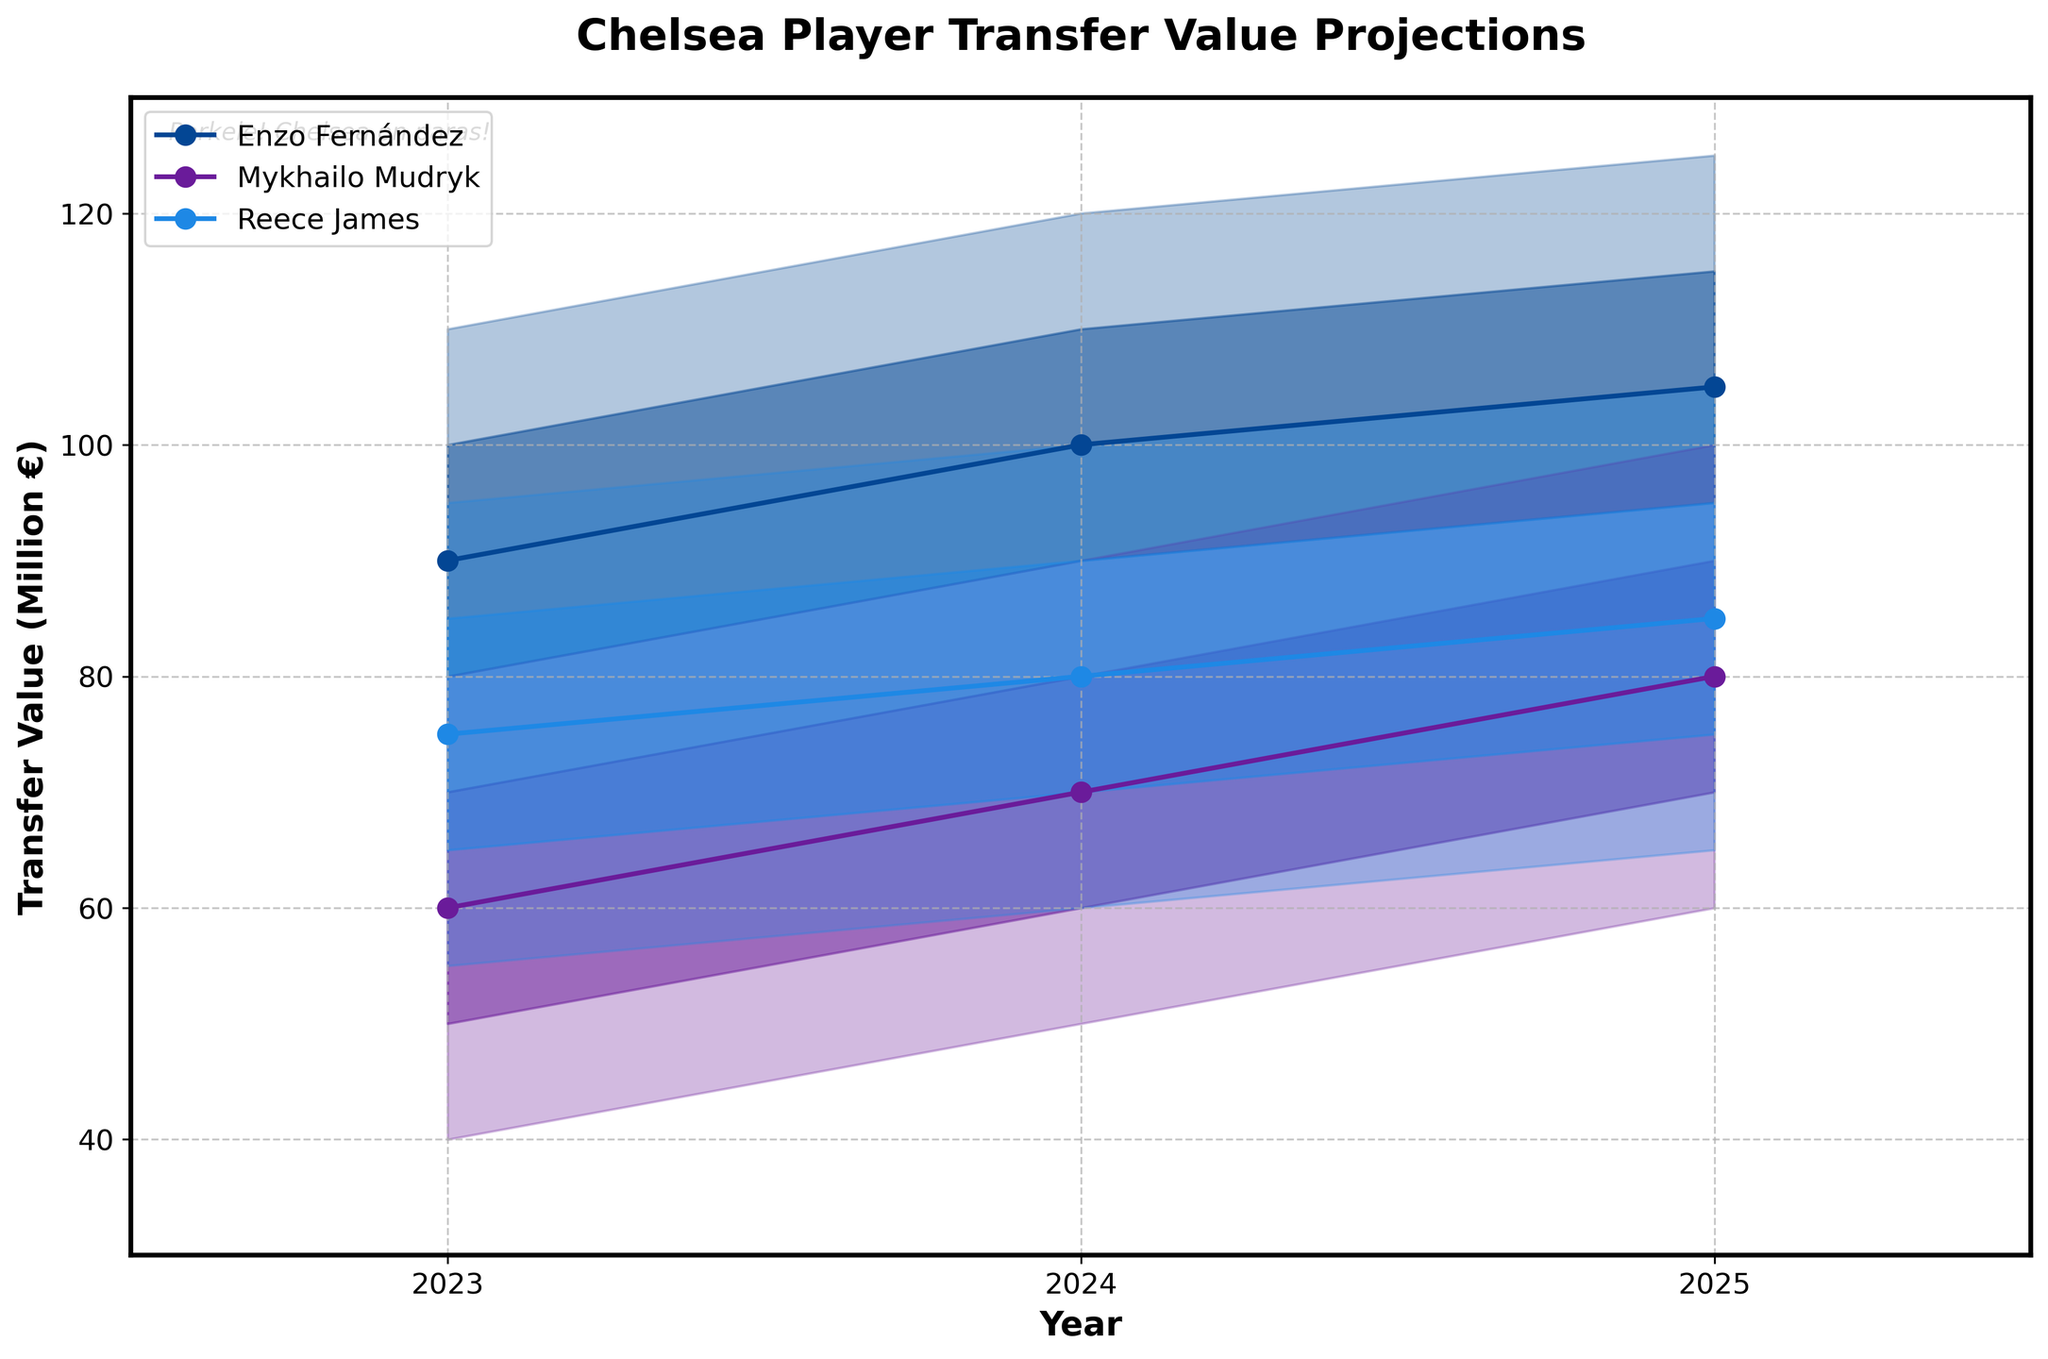What's the title of the figure? The title is usually found at the top center of the chart and summarizes what the chart is about. In this case, it reads "Chelsea Player Transfer Value Projections."
Answer: Chelsea Player Transfer Value Projections What is the transfer value range for Enzo Fernández in 2023? To find the transfer value range, look at the low and high values for Enzo Fernández in 2023. These are represented by the bounds of the shaded area. The low value is 70 million €, and the high value is 110 million €.
Answer: 70 to 110 million € How many years are shown in the figure? Count the number of distinct years on the x-axis, which range from 2023 to 2025. This includes three years: 2023, 2024, and 2025.
Answer: 3 What is the median transfer value for Reece James in 2024? The median transfer value is represented by the solid line with markers. For Reece James in 2024, find the value corresponding to the year 2024.
Answer: 80 million € Which player has the highest median transfer value in 2025? Compare the median values for all players in 2025. Enzo Fernández has a median value of 105 million €, Mykhailo Mudryk has 80 million €, and Reece James has 85 million €.
Answer: Enzo Fernández Which player's transfer value has the smallest range in 2025? Calculate the range (High - Low) for each player in 2025. Enzo Fernández: 125 - 85 = 40 million €, Mykhailo Mudryk: 100 - 60 = 40 million €, Reece James: 105 - 65 = 40 million €. All players have the same range here.
Answer: Enzo Fernández, Mykhailo Mudryk, and Reece James How does the median transfer value of Mykhailo Mudryk change from 2023 to 2025? Look at the median values for Mykhailo Mudryk for each year. The values are 60 million € in 2023, 70 million € in 2024, and 80 million € in 2025. The change can be calculated year-by-year.
Answer: Increases by 20 million € Between which years does Enzo Fernández show the highest increase in his low transfer value? Compare Enzo Fernández's low values over the years. From 2023 to 2024, it increases from 70 to 80 (10 million €). From 2024 to 2025, it increases from 80 to 85 (5 million €).
Answer: 2023 to 2024 